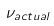<formula> <loc_0><loc_0><loc_500><loc_500>\nu _ { a c t u a l }</formula> 